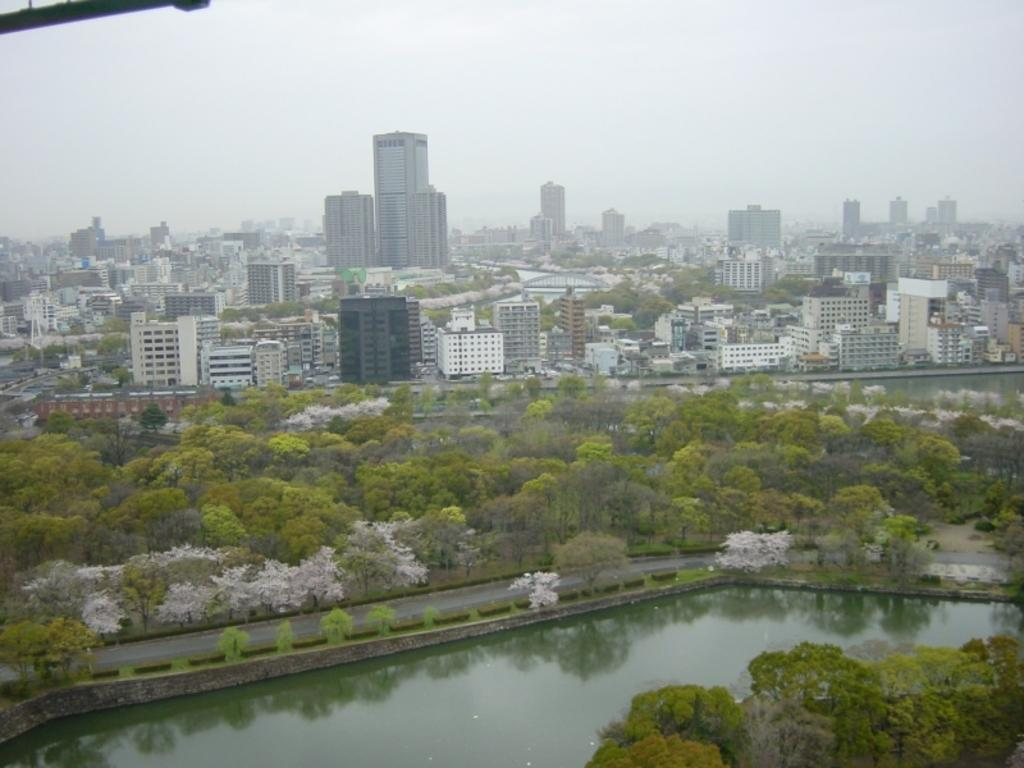What type of view is shown in the image? The image is an aerial view of a city. What can be seen in the background of the image? There are many buildings in the background of the image. What type of vegetation is present in front of the buildings? Trees are present in front of the buildings. What body of water is visible in the image? There is a canal in the front of the image. What is visible above the image? The sky is visible above the image. Where is the box located in the image? There is no box present in the image. Is the image taken during the morning? The time of day is not mentioned in the facts, so it cannot be determined from the image. Can you see any quicksand in the image? There is no quicksand present in the image. 